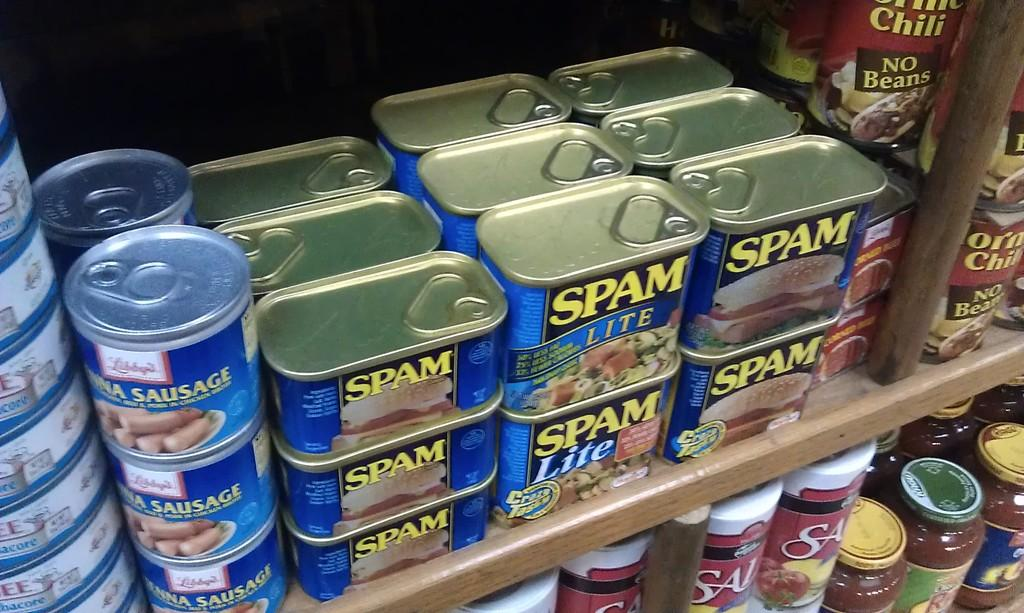<image>
Create a compact narrative representing the image presented. Various spam cans are on the shelf including the lite one. 